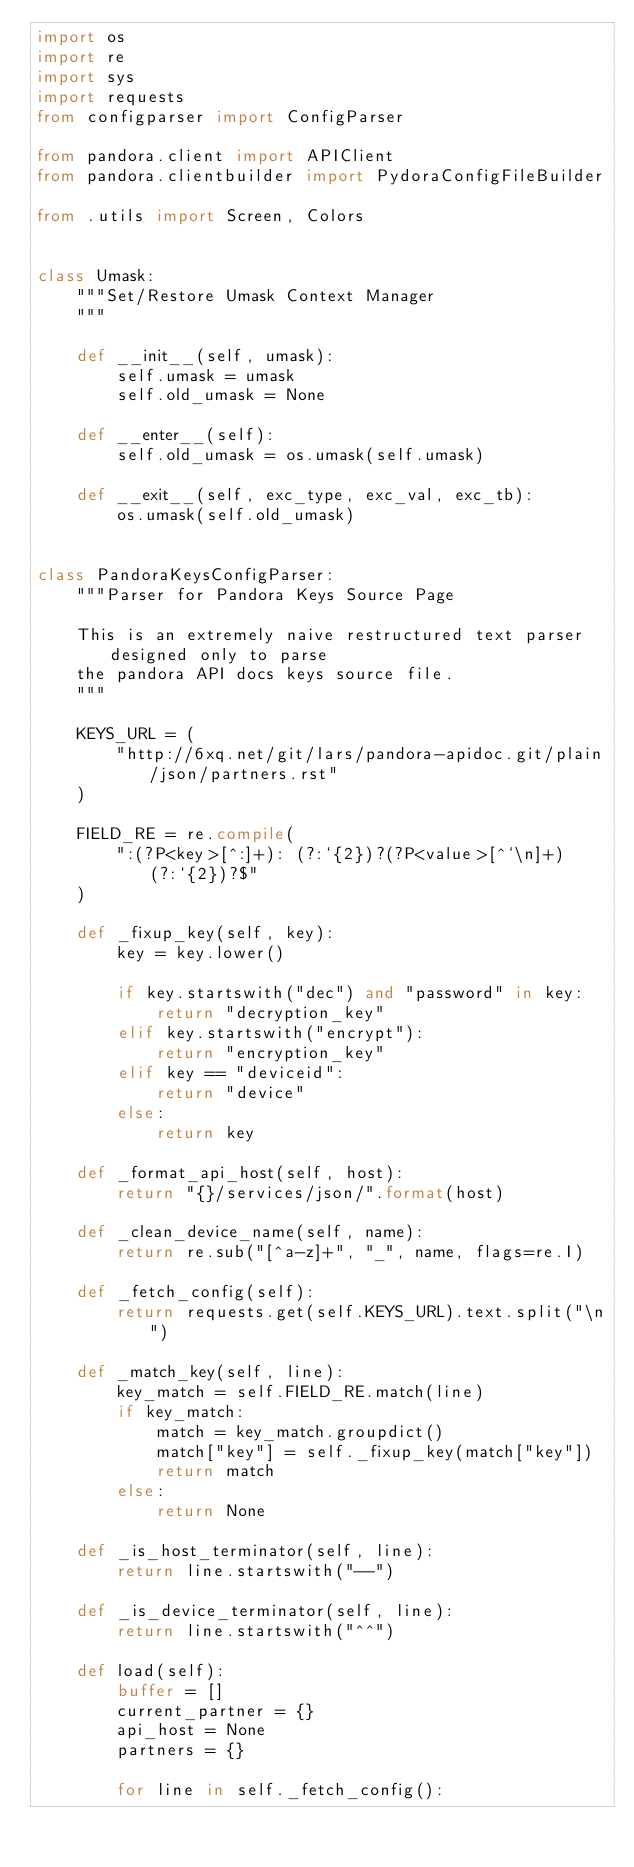<code> <loc_0><loc_0><loc_500><loc_500><_Python_>import os
import re
import sys
import requests
from configparser import ConfigParser

from pandora.client import APIClient
from pandora.clientbuilder import PydoraConfigFileBuilder

from .utils import Screen, Colors


class Umask:
    """Set/Restore Umask Context Manager
    """

    def __init__(self, umask):
        self.umask = umask
        self.old_umask = None

    def __enter__(self):
        self.old_umask = os.umask(self.umask)

    def __exit__(self, exc_type, exc_val, exc_tb):
        os.umask(self.old_umask)


class PandoraKeysConfigParser:
    """Parser for Pandora Keys Source Page

    This is an extremely naive restructured text parser designed only to parse
    the pandora API docs keys source file.
    """

    KEYS_URL = (
        "http://6xq.net/git/lars/pandora-apidoc.git/plain/json/partners.rst"
    )

    FIELD_RE = re.compile(
        ":(?P<key>[^:]+): (?:`{2})?(?P<value>[^`\n]+)(?:`{2})?$"
    )

    def _fixup_key(self, key):
        key = key.lower()

        if key.startswith("dec") and "password" in key:
            return "decryption_key"
        elif key.startswith("encrypt"):
            return "encryption_key"
        elif key == "deviceid":
            return "device"
        else:
            return key

    def _format_api_host(self, host):
        return "{}/services/json/".format(host)

    def _clean_device_name(self, name):
        return re.sub("[^a-z]+", "_", name, flags=re.I)

    def _fetch_config(self):
        return requests.get(self.KEYS_URL).text.split("\n")

    def _match_key(self, line):
        key_match = self.FIELD_RE.match(line)
        if key_match:
            match = key_match.groupdict()
            match["key"] = self._fixup_key(match["key"])
            return match
        else:
            return None

    def _is_host_terminator(self, line):
        return line.startswith("--")

    def _is_device_terminator(self, line):
        return line.startswith("^^")

    def load(self):
        buffer = []
        current_partner = {}
        api_host = None
        partners = {}

        for line in self._fetch_config():</code> 